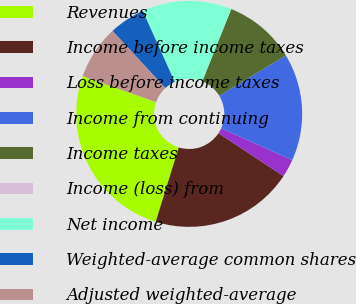Convert chart. <chart><loc_0><loc_0><loc_500><loc_500><pie_chart><fcel>Revenues<fcel>Income before income taxes<fcel>Loss before income taxes<fcel>Income from continuing<fcel>Income taxes<fcel>Income (loss) from<fcel>Net income<fcel>Weighted-average common shares<fcel>Adjusted weighted-average<nl><fcel>25.64%<fcel>20.51%<fcel>2.56%<fcel>15.38%<fcel>10.26%<fcel>0.0%<fcel>12.82%<fcel>5.13%<fcel>7.69%<nl></chart> 